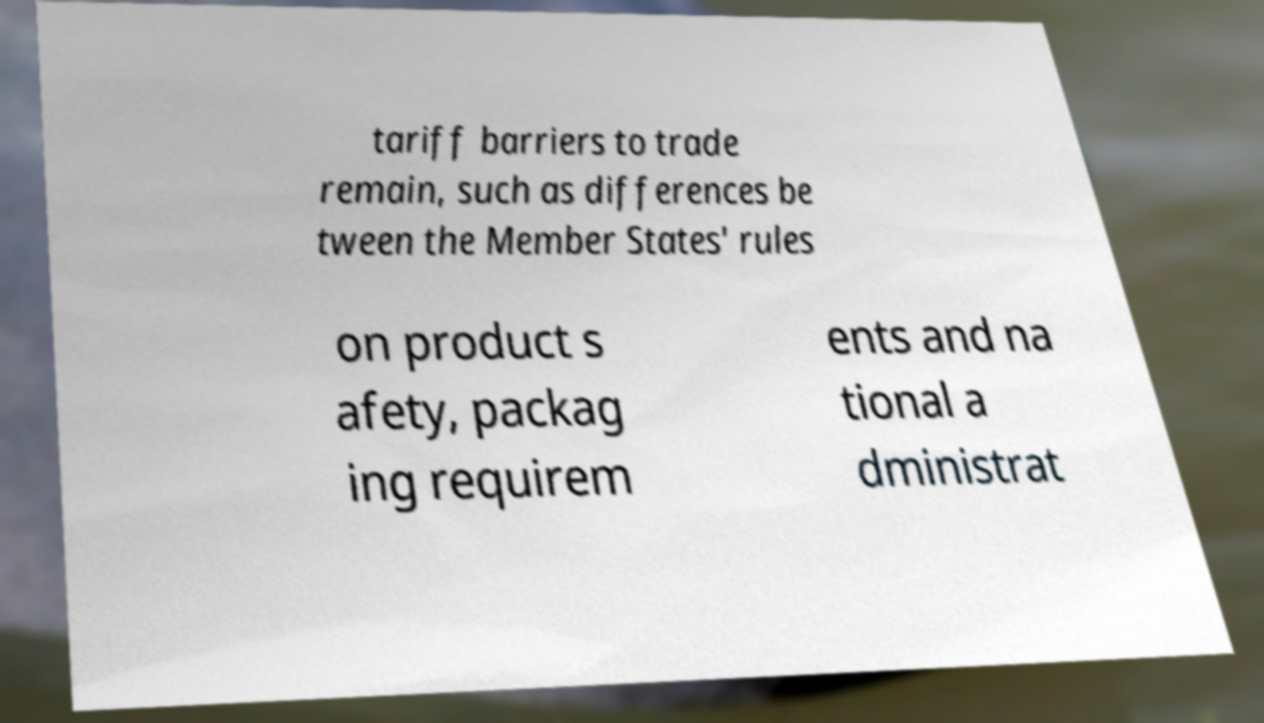Can you read and provide the text displayed in the image?This photo seems to have some interesting text. Can you extract and type it out for me? tariff barriers to trade remain, such as differences be tween the Member States' rules on product s afety, packag ing requirem ents and na tional a dministrat 